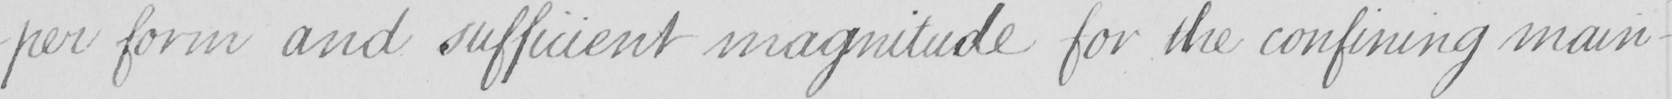Transcribe the text shown in this historical manuscript line. -per form and sufficient magnitude for the confining main- 